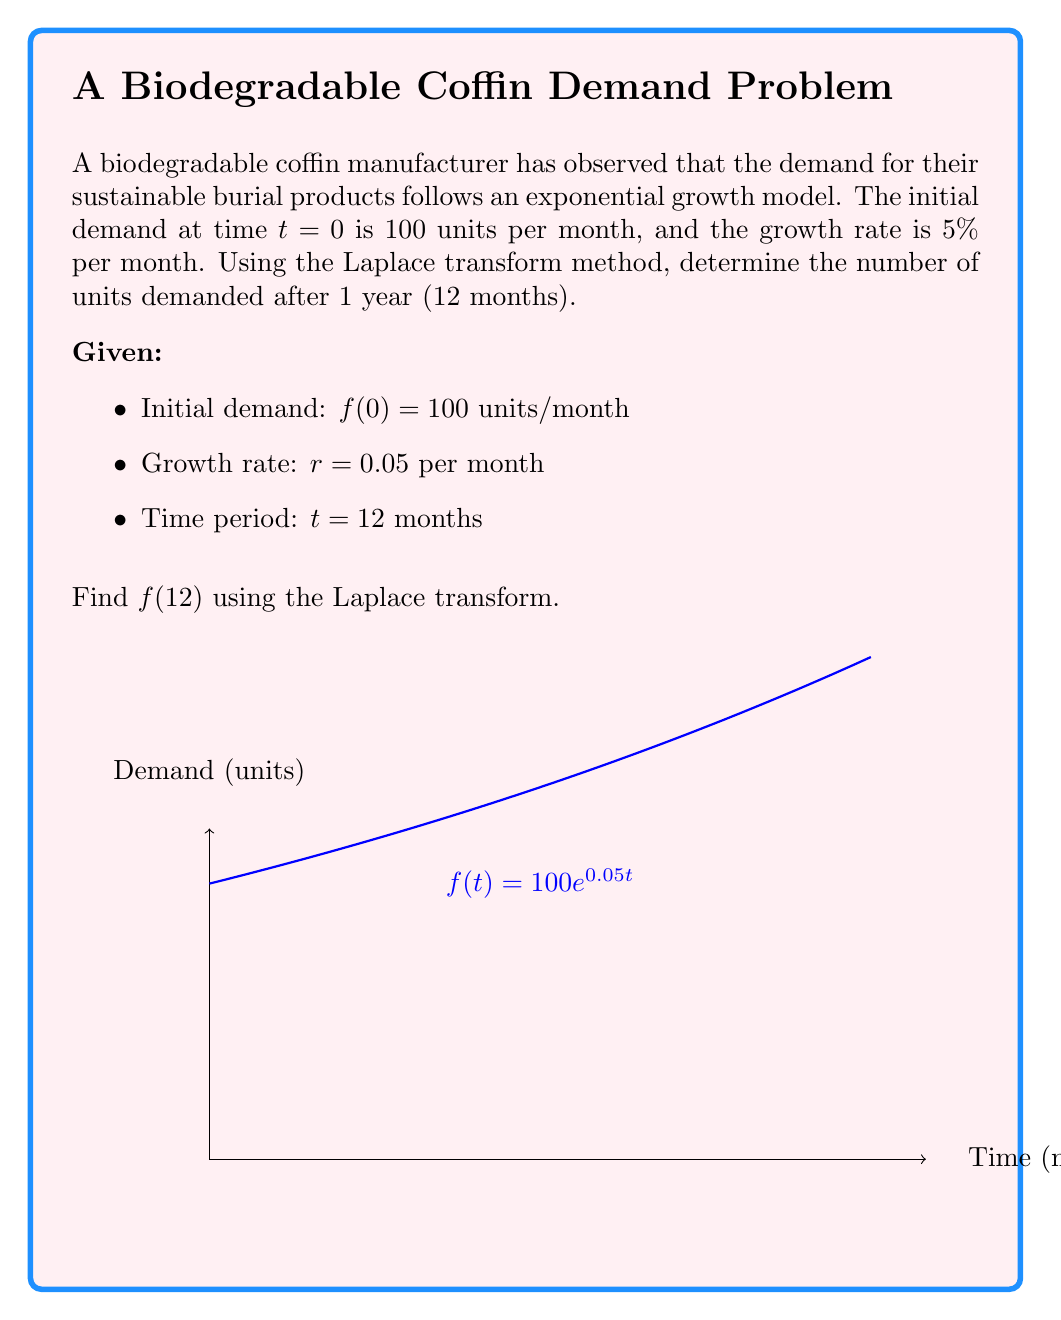Teach me how to tackle this problem. Let's solve this problem step by step using the Laplace transform method:

1) The exponential growth model is given by:
   $$f(t) = 100e^{0.05t}$$

2) The Laplace transform of $f(t)$ is:
   $$F(s) = \mathcal{L}\{f(t)\} = \mathcal{L}\{100e^{0.05t}\}$$

3) Using the Laplace transform property for exponential functions:
   $$\mathcal{L}\{e^{at}\} = \frac{1}{s-a}$$

4) Applying this property to our function:
   $$F(s) = 100 \cdot \frac{1}{s-0.05}$$

5) To find $f(12)$, we need to use the inverse Laplace transform and evaluate at $t=12$:
   $$f(12) = \mathcal{L}^{-1}\{F(s)\}|_{t=12}$$

6) The inverse Laplace transform of $\frac{1}{s-a}$ is $e^{at}$, so:
   $$f(12) = 100e^{0.05 \cdot 12}$$

7) Calculating the result:
   $$f(12) = 100e^{0.6} \approx 182.21$$

Therefore, after 12 months, the demand will be approximately 182.21 units per month.
Answer: 182.21 units/month 